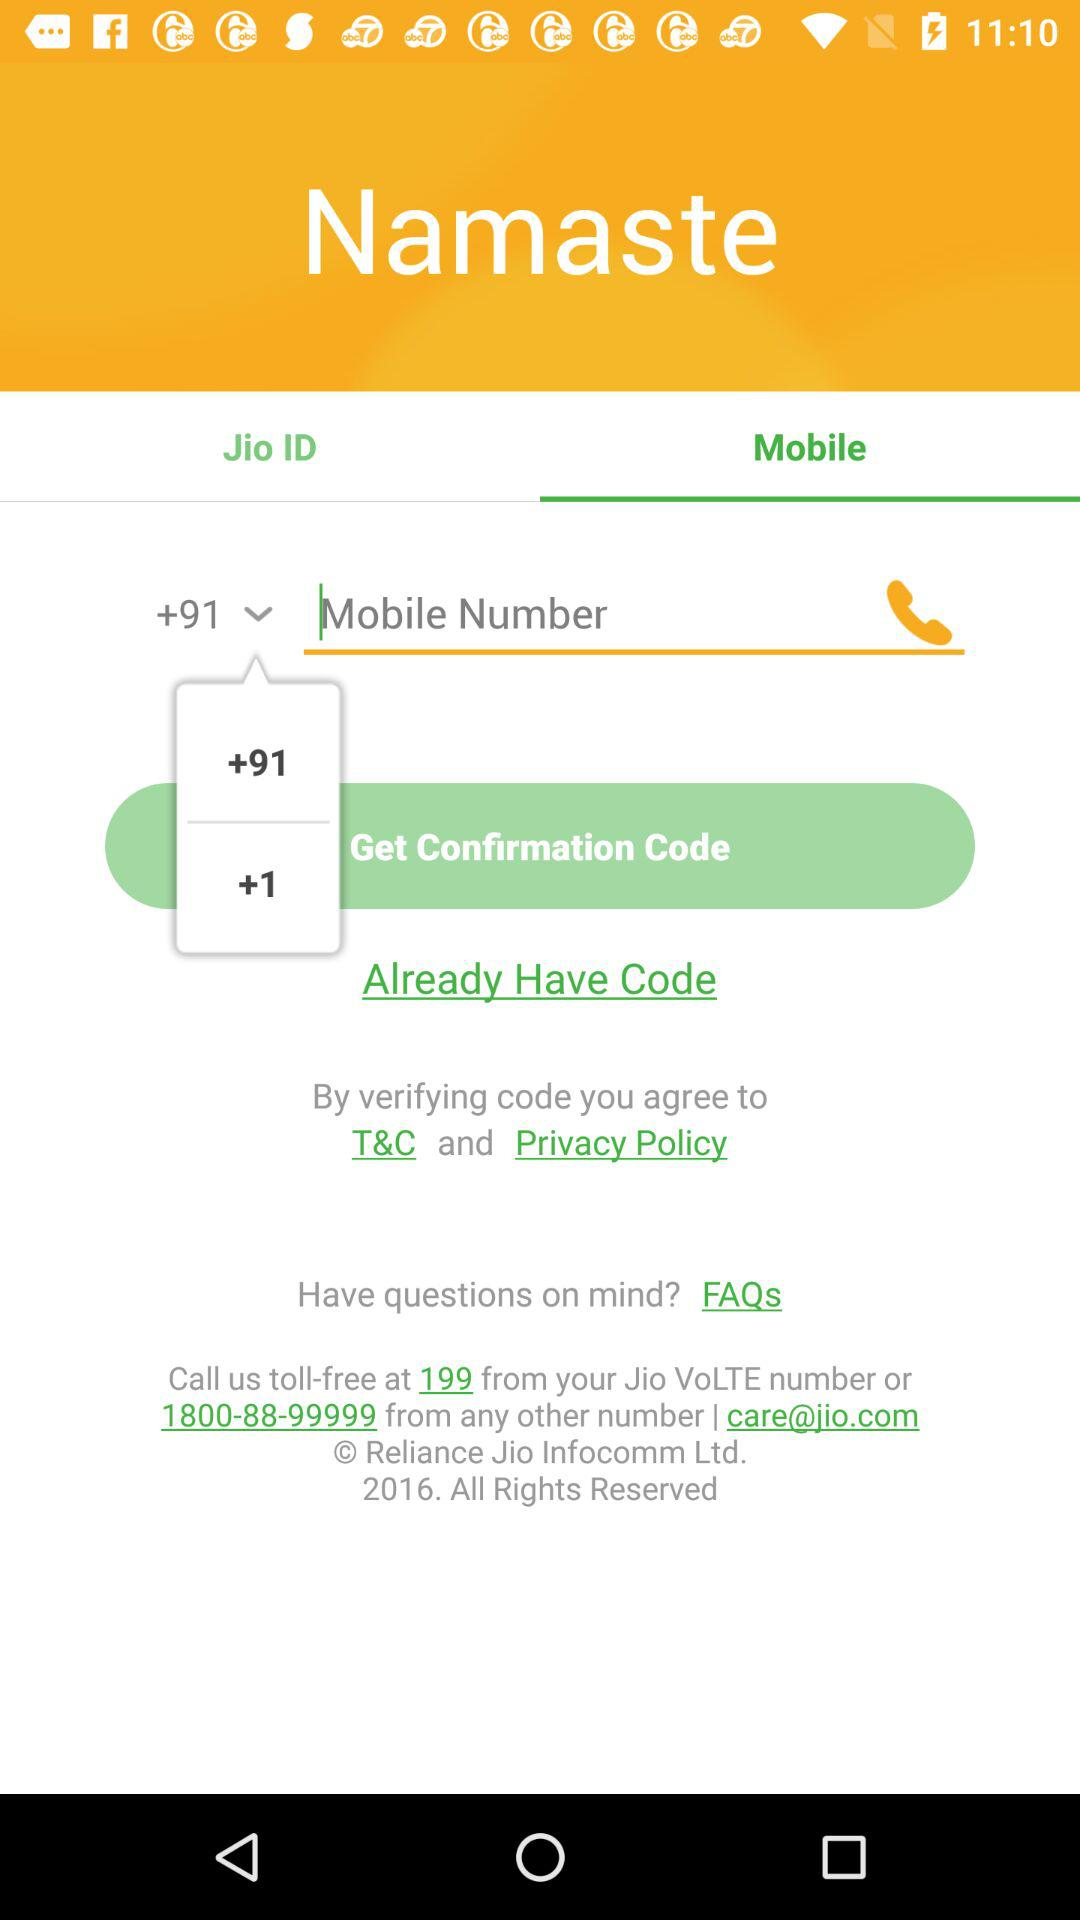What is the tollfree number for any queries? The tollfree numbers for any queries are 199 and 1800-88-99999. 